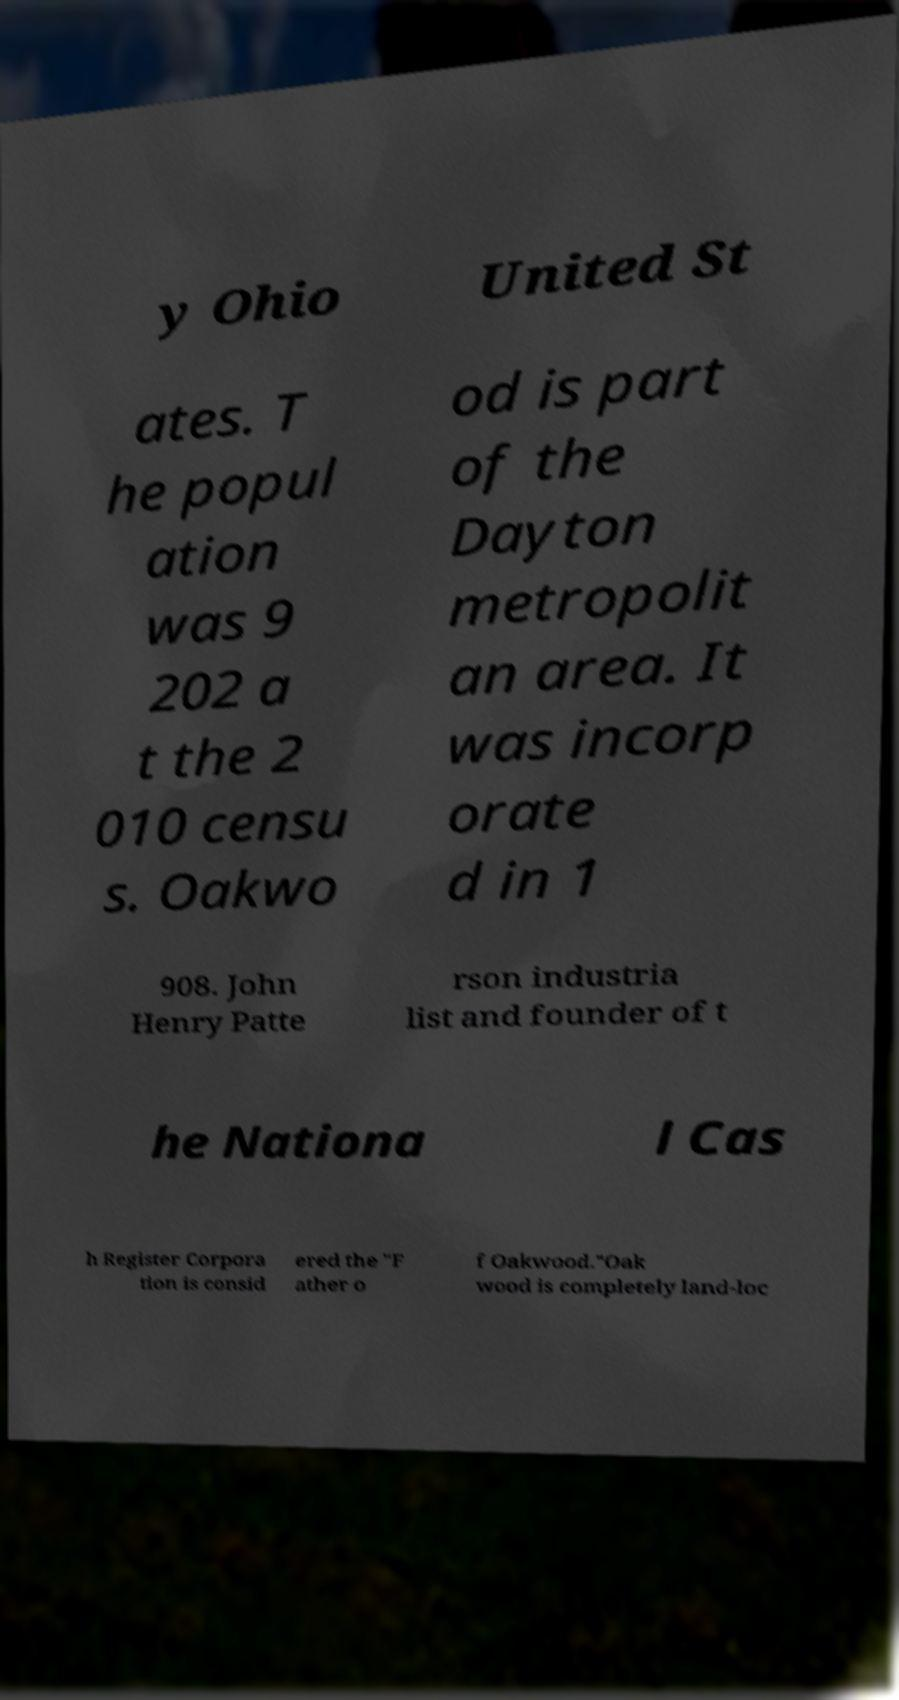Could you extract and type out the text from this image? y Ohio United St ates. T he popul ation was 9 202 a t the 2 010 censu s. Oakwo od is part of the Dayton metropolit an area. It was incorp orate d in 1 908. John Henry Patte rson industria list and founder of t he Nationa l Cas h Register Corpora tion is consid ered the "F ather o f Oakwood."Oak wood is completely land-loc 